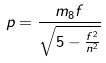Convert formula to latex. <formula><loc_0><loc_0><loc_500><loc_500>p = \frac { m _ { 8 } f } { \sqrt { 5 - \frac { f ^ { 2 } } { n ^ { 2 } } } }</formula> 